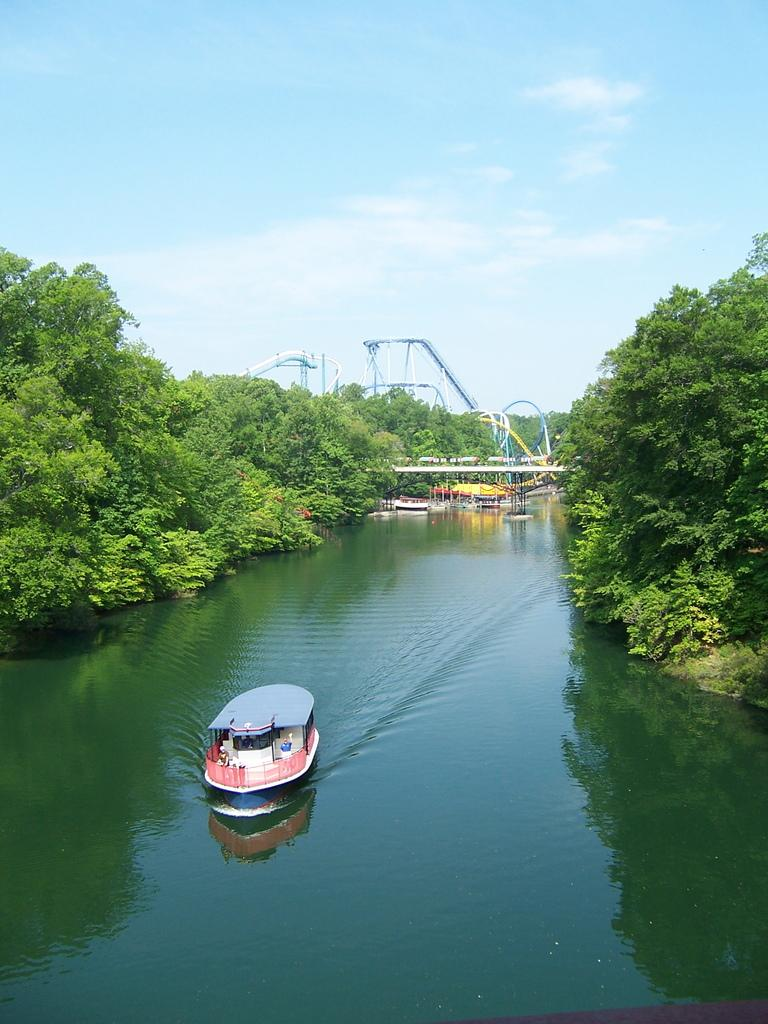What is the main subject of the image? The main subject of the image is a boat. Where is the boat located in the image? The boat is on the water. What other natural elements can be seen in the image? There are trees and the sky visible in the image. What man-made structure is present in the image? There is a bridge in the image. Can you describe the sky in the image? The sky is visible in the background of the image, and there are clouds present. What type of earth is visible in the image? There is no specific type of earth mentioned or visible in the image; it primarily features a boat on the water, trees, a bridge, and the sky. 